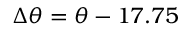<formula> <loc_0><loc_0><loc_500><loc_500>\Delta \theta = \theta - 1 7 . 7 5</formula> 